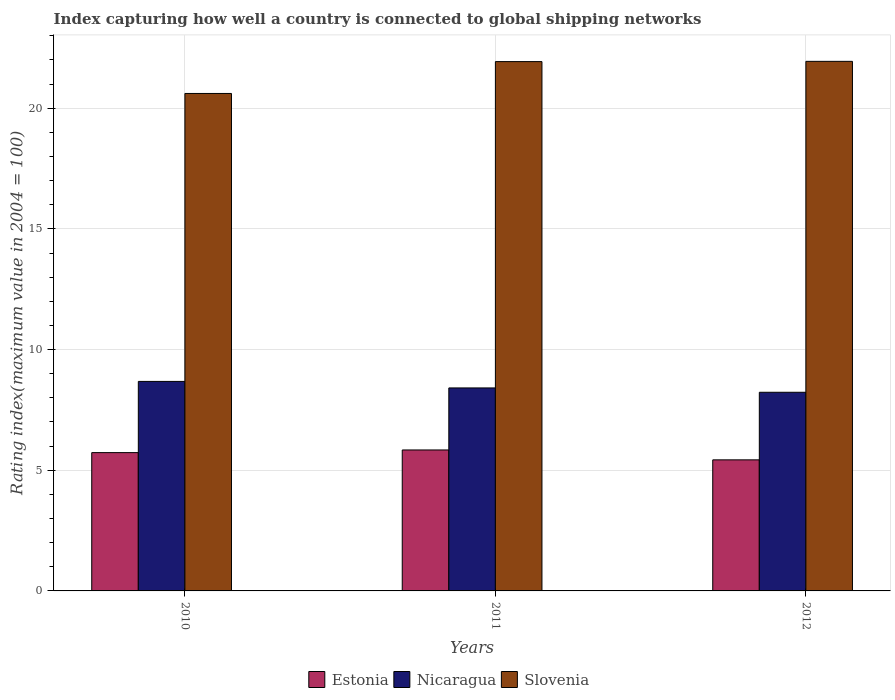How many different coloured bars are there?
Provide a succinct answer. 3. How many groups of bars are there?
Ensure brevity in your answer.  3. Are the number of bars per tick equal to the number of legend labels?
Provide a succinct answer. Yes. How many bars are there on the 1st tick from the left?
Make the answer very short. 3. How many bars are there on the 3rd tick from the right?
Your answer should be compact. 3. What is the label of the 3rd group of bars from the left?
Your response must be concise. 2012. In how many cases, is the number of bars for a given year not equal to the number of legend labels?
Provide a short and direct response. 0. What is the rating index in Nicaragua in 2011?
Give a very brief answer. 8.41. Across all years, what is the maximum rating index in Estonia?
Give a very brief answer. 5.84. Across all years, what is the minimum rating index in Slovenia?
Give a very brief answer. 20.61. In which year was the rating index in Estonia maximum?
Keep it short and to the point. 2011. In which year was the rating index in Nicaragua minimum?
Your response must be concise. 2012. What is the total rating index in Nicaragua in the graph?
Offer a very short reply. 25.32. What is the difference between the rating index in Slovenia in 2010 and that in 2011?
Ensure brevity in your answer.  -1.32. What is the difference between the rating index in Slovenia in 2010 and the rating index in Nicaragua in 2012?
Your answer should be very brief. 12.38. What is the average rating index in Slovenia per year?
Your answer should be very brief. 21.49. In the year 2010, what is the difference between the rating index in Nicaragua and rating index in Slovenia?
Make the answer very short. -11.93. What is the ratio of the rating index in Nicaragua in 2010 to that in 2012?
Make the answer very short. 1.05. Is the rating index in Estonia in 2010 less than that in 2012?
Ensure brevity in your answer.  No. Is the difference between the rating index in Nicaragua in 2010 and 2011 greater than the difference between the rating index in Slovenia in 2010 and 2011?
Keep it short and to the point. Yes. What is the difference between the highest and the second highest rating index in Nicaragua?
Provide a short and direct response. 0.27. What is the difference between the highest and the lowest rating index in Estonia?
Provide a succinct answer. 0.41. In how many years, is the rating index in Slovenia greater than the average rating index in Slovenia taken over all years?
Keep it short and to the point. 2. Is the sum of the rating index in Slovenia in 2011 and 2012 greater than the maximum rating index in Nicaragua across all years?
Give a very brief answer. Yes. What does the 1st bar from the left in 2012 represents?
Offer a very short reply. Estonia. What does the 3rd bar from the right in 2012 represents?
Your answer should be compact. Estonia. Is it the case that in every year, the sum of the rating index in Estonia and rating index in Slovenia is greater than the rating index in Nicaragua?
Keep it short and to the point. Yes. How many years are there in the graph?
Ensure brevity in your answer.  3. Are the values on the major ticks of Y-axis written in scientific E-notation?
Your answer should be very brief. No. Does the graph contain any zero values?
Offer a terse response. No. How are the legend labels stacked?
Your answer should be very brief. Horizontal. What is the title of the graph?
Your answer should be compact. Index capturing how well a country is connected to global shipping networks. What is the label or title of the X-axis?
Your answer should be very brief. Years. What is the label or title of the Y-axis?
Your answer should be very brief. Rating index(maximum value in 2004 = 100). What is the Rating index(maximum value in 2004 = 100) in Estonia in 2010?
Offer a terse response. 5.73. What is the Rating index(maximum value in 2004 = 100) of Nicaragua in 2010?
Give a very brief answer. 8.68. What is the Rating index(maximum value in 2004 = 100) of Slovenia in 2010?
Your answer should be compact. 20.61. What is the Rating index(maximum value in 2004 = 100) in Estonia in 2011?
Provide a short and direct response. 5.84. What is the Rating index(maximum value in 2004 = 100) of Nicaragua in 2011?
Your answer should be compact. 8.41. What is the Rating index(maximum value in 2004 = 100) in Slovenia in 2011?
Ensure brevity in your answer.  21.93. What is the Rating index(maximum value in 2004 = 100) of Estonia in 2012?
Your answer should be compact. 5.43. What is the Rating index(maximum value in 2004 = 100) in Nicaragua in 2012?
Your response must be concise. 8.23. What is the Rating index(maximum value in 2004 = 100) of Slovenia in 2012?
Your response must be concise. 21.94. Across all years, what is the maximum Rating index(maximum value in 2004 = 100) of Estonia?
Provide a short and direct response. 5.84. Across all years, what is the maximum Rating index(maximum value in 2004 = 100) in Nicaragua?
Your answer should be compact. 8.68. Across all years, what is the maximum Rating index(maximum value in 2004 = 100) in Slovenia?
Offer a very short reply. 21.94. Across all years, what is the minimum Rating index(maximum value in 2004 = 100) in Estonia?
Offer a terse response. 5.43. Across all years, what is the minimum Rating index(maximum value in 2004 = 100) of Nicaragua?
Your answer should be very brief. 8.23. Across all years, what is the minimum Rating index(maximum value in 2004 = 100) in Slovenia?
Offer a very short reply. 20.61. What is the total Rating index(maximum value in 2004 = 100) in Estonia in the graph?
Ensure brevity in your answer.  17. What is the total Rating index(maximum value in 2004 = 100) of Nicaragua in the graph?
Provide a short and direct response. 25.32. What is the total Rating index(maximum value in 2004 = 100) of Slovenia in the graph?
Ensure brevity in your answer.  64.48. What is the difference between the Rating index(maximum value in 2004 = 100) in Estonia in 2010 and that in 2011?
Offer a terse response. -0.11. What is the difference between the Rating index(maximum value in 2004 = 100) in Nicaragua in 2010 and that in 2011?
Offer a very short reply. 0.27. What is the difference between the Rating index(maximum value in 2004 = 100) of Slovenia in 2010 and that in 2011?
Ensure brevity in your answer.  -1.32. What is the difference between the Rating index(maximum value in 2004 = 100) of Nicaragua in 2010 and that in 2012?
Ensure brevity in your answer.  0.45. What is the difference between the Rating index(maximum value in 2004 = 100) in Slovenia in 2010 and that in 2012?
Offer a very short reply. -1.33. What is the difference between the Rating index(maximum value in 2004 = 100) of Estonia in 2011 and that in 2012?
Provide a short and direct response. 0.41. What is the difference between the Rating index(maximum value in 2004 = 100) in Nicaragua in 2011 and that in 2012?
Ensure brevity in your answer.  0.18. What is the difference between the Rating index(maximum value in 2004 = 100) in Slovenia in 2011 and that in 2012?
Your answer should be very brief. -0.01. What is the difference between the Rating index(maximum value in 2004 = 100) of Estonia in 2010 and the Rating index(maximum value in 2004 = 100) of Nicaragua in 2011?
Your answer should be compact. -2.68. What is the difference between the Rating index(maximum value in 2004 = 100) in Estonia in 2010 and the Rating index(maximum value in 2004 = 100) in Slovenia in 2011?
Offer a very short reply. -16.2. What is the difference between the Rating index(maximum value in 2004 = 100) in Nicaragua in 2010 and the Rating index(maximum value in 2004 = 100) in Slovenia in 2011?
Provide a succinct answer. -13.25. What is the difference between the Rating index(maximum value in 2004 = 100) of Estonia in 2010 and the Rating index(maximum value in 2004 = 100) of Slovenia in 2012?
Offer a terse response. -16.21. What is the difference between the Rating index(maximum value in 2004 = 100) of Nicaragua in 2010 and the Rating index(maximum value in 2004 = 100) of Slovenia in 2012?
Your response must be concise. -13.26. What is the difference between the Rating index(maximum value in 2004 = 100) of Estonia in 2011 and the Rating index(maximum value in 2004 = 100) of Nicaragua in 2012?
Provide a succinct answer. -2.39. What is the difference between the Rating index(maximum value in 2004 = 100) in Estonia in 2011 and the Rating index(maximum value in 2004 = 100) in Slovenia in 2012?
Provide a short and direct response. -16.1. What is the difference between the Rating index(maximum value in 2004 = 100) in Nicaragua in 2011 and the Rating index(maximum value in 2004 = 100) in Slovenia in 2012?
Give a very brief answer. -13.53. What is the average Rating index(maximum value in 2004 = 100) in Estonia per year?
Make the answer very short. 5.67. What is the average Rating index(maximum value in 2004 = 100) of Nicaragua per year?
Give a very brief answer. 8.44. What is the average Rating index(maximum value in 2004 = 100) in Slovenia per year?
Offer a terse response. 21.49. In the year 2010, what is the difference between the Rating index(maximum value in 2004 = 100) in Estonia and Rating index(maximum value in 2004 = 100) in Nicaragua?
Provide a succinct answer. -2.95. In the year 2010, what is the difference between the Rating index(maximum value in 2004 = 100) of Estonia and Rating index(maximum value in 2004 = 100) of Slovenia?
Keep it short and to the point. -14.88. In the year 2010, what is the difference between the Rating index(maximum value in 2004 = 100) of Nicaragua and Rating index(maximum value in 2004 = 100) of Slovenia?
Give a very brief answer. -11.93. In the year 2011, what is the difference between the Rating index(maximum value in 2004 = 100) in Estonia and Rating index(maximum value in 2004 = 100) in Nicaragua?
Make the answer very short. -2.57. In the year 2011, what is the difference between the Rating index(maximum value in 2004 = 100) of Estonia and Rating index(maximum value in 2004 = 100) of Slovenia?
Your response must be concise. -16.09. In the year 2011, what is the difference between the Rating index(maximum value in 2004 = 100) in Nicaragua and Rating index(maximum value in 2004 = 100) in Slovenia?
Provide a short and direct response. -13.52. In the year 2012, what is the difference between the Rating index(maximum value in 2004 = 100) in Estonia and Rating index(maximum value in 2004 = 100) in Slovenia?
Make the answer very short. -16.51. In the year 2012, what is the difference between the Rating index(maximum value in 2004 = 100) in Nicaragua and Rating index(maximum value in 2004 = 100) in Slovenia?
Your answer should be very brief. -13.71. What is the ratio of the Rating index(maximum value in 2004 = 100) in Estonia in 2010 to that in 2011?
Offer a very short reply. 0.98. What is the ratio of the Rating index(maximum value in 2004 = 100) of Nicaragua in 2010 to that in 2011?
Ensure brevity in your answer.  1.03. What is the ratio of the Rating index(maximum value in 2004 = 100) in Slovenia in 2010 to that in 2011?
Keep it short and to the point. 0.94. What is the ratio of the Rating index(maximum value in 2004 = 100) in Estonia in 2010 to that in 2012?
Keep it short and to the point. 1.06. What is the ratio of the Rating index(maximum value in 2004 = 100) in Nicaragua in 2010 to that in 2012?
Make the answer very short. 1.05. What is the ratio of the Rating index(maximum value in 2004 = 100) in Slovenia in 2010 to that in 2012?
Provide a succinct answer. 0.94. What is the ratio of the Rating index(maximum value in 2004 = 100) in Estonia in 2011 to that in 2012?
Your answer should be compact. 1.08. What is the ratio of the Rating index(maximum value in 2004 = 100) of Nicaragua in 2011 to that in 2012?
Your response must be concise. 1.02. What is the difference between the highest and the second highest Rating index(maximum value in 2004 = 100) of Estonia?
Your response must be concise. 0.11. What is the difference between the highest and the second highest Rating index(maximum value in 2004 = 100) of Nicaragua?
Make the answer very short. 0.27. What is the difference between the highest and the second highest Rating index(maximum value in 2004 = 100) in Slovenia?
Provide a short and direct response. 0.01. What is the difference between the highest and the lowest Rating index(maximum value in 2004 = 100) of Estonia?
Your answer should be very brief. 0.41. What is the difference between the highest and the lowest Rating index(maximum value in 2004 = 100) in Nicaragua?
Your answer should be compact. 0.45. What is the difference between the highest and the lowest Rating index(maximum value in 2004 = 100) of Slovenia?
Your answer should be very brief. 1.33. 